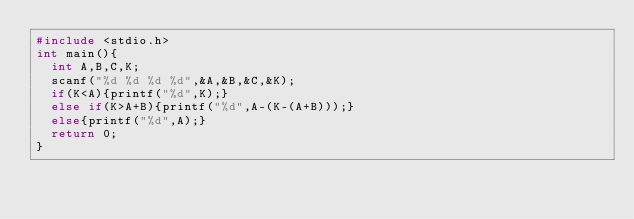<code> <loc_0><loc_0><loc_500><loc_500><_C_>#include <stdio.h>
int main(){
  int A,B,C,K;
  scanf("%d %d %d %d",&A,&B,&C,&K);
  if(K<A){printf("%d",K);}
  else if(K>A+B){printf("%d",A-(K-(A+B)));}
  else{printf("%d",A);}
  return 0;
}</code> 